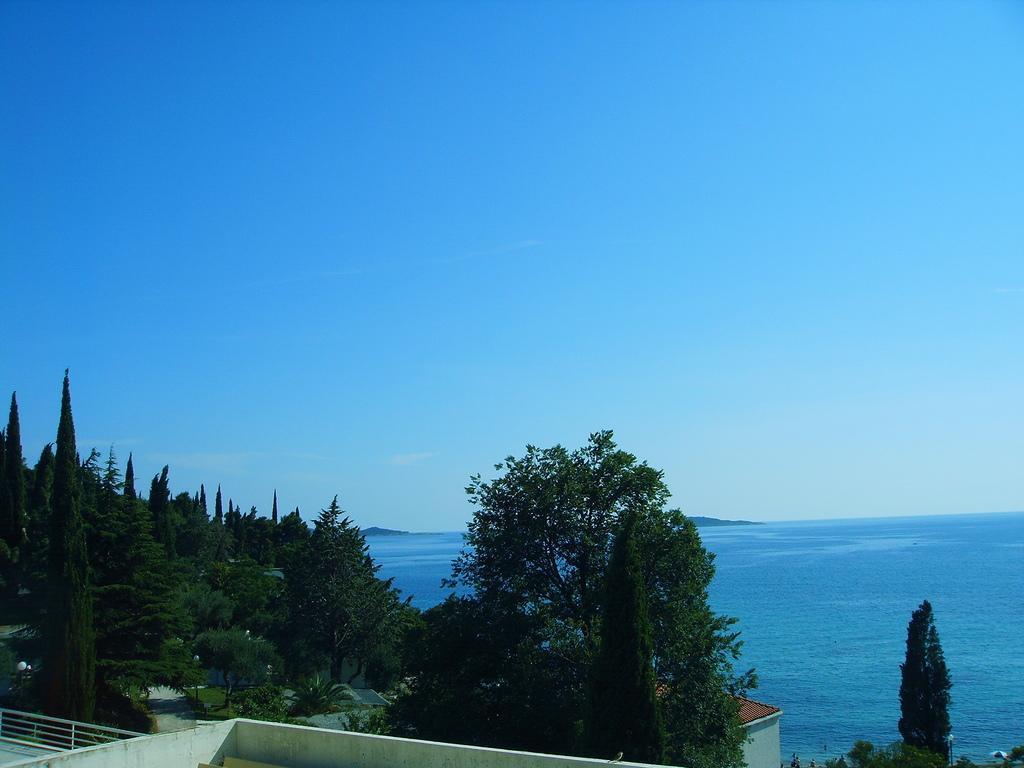Please provide a concise description of this image. In this image we can see water, trees, plants, road, buildings, hill, sky and clouds. 